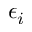<formula> <loc_0><loc_0><loc_500><loc_500>\epsilon _ { i }</formula> 